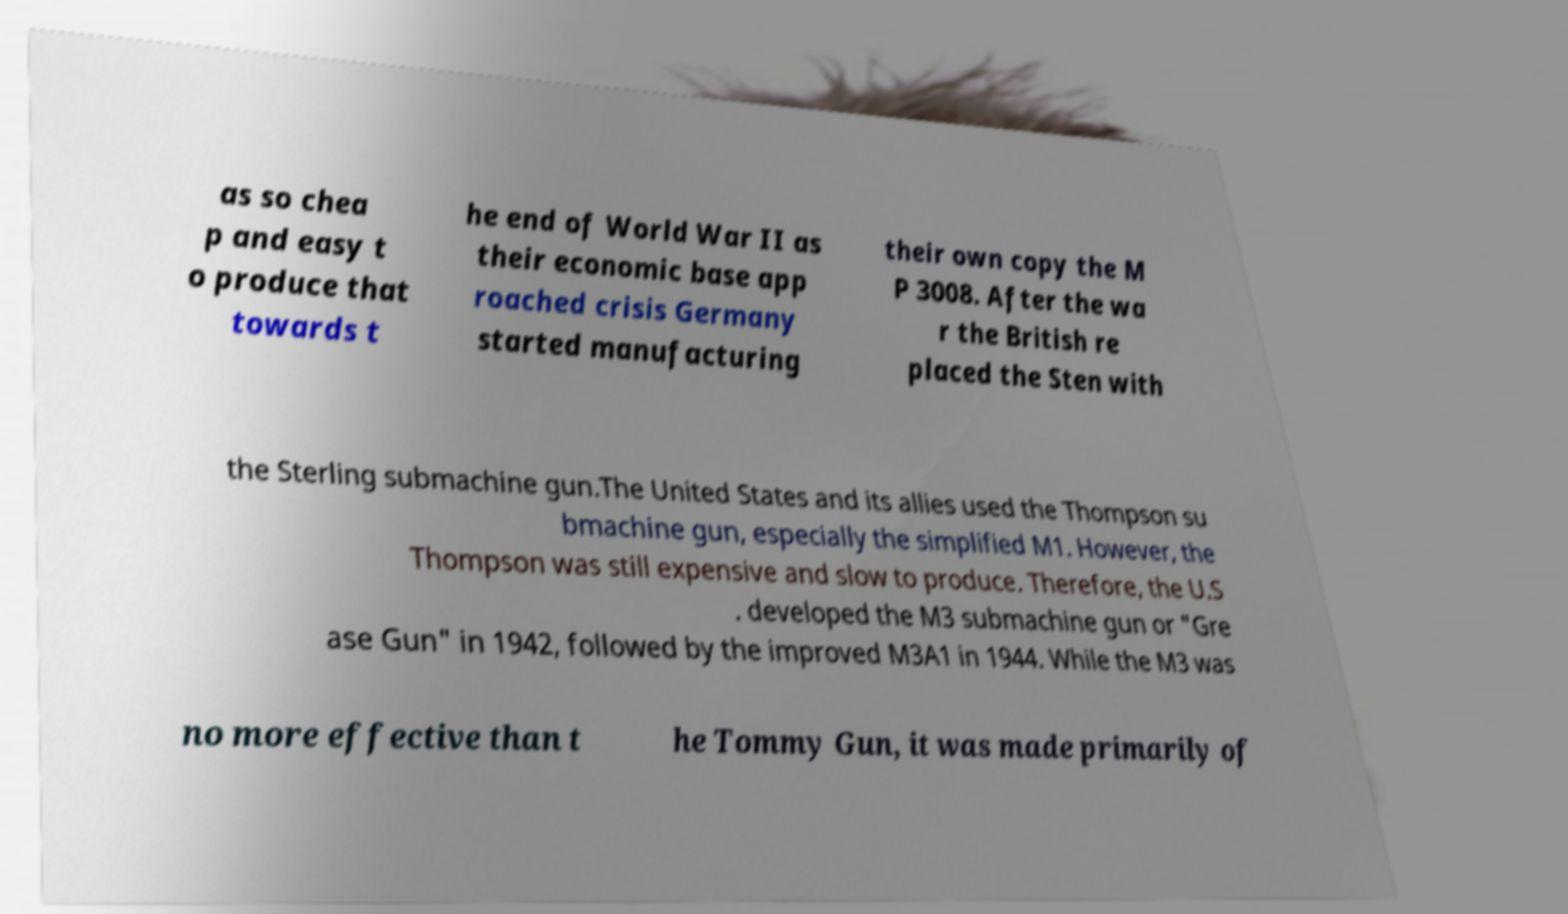Could you extract and type out the text from this image? as so chea p and easy t o produce that towards t he end of World War II as their economic base app roached crisis Germany started manufacturing their own copy the M P 3008. After the wa r the British re placed the Sten with the Sterling submachine gun.The United States and its allies used the Thompson su bmachine gun, especially the simplified M1. However, the Thompson was still expensive and slow to produce. Therefore, the U.S . developed the M3 submachine gun or "Gre ase Gun" in 1942, followed by the improved M3A1 in 1944. While the M3 was no more effective than t he Tommy Gun, it was made primarily of 